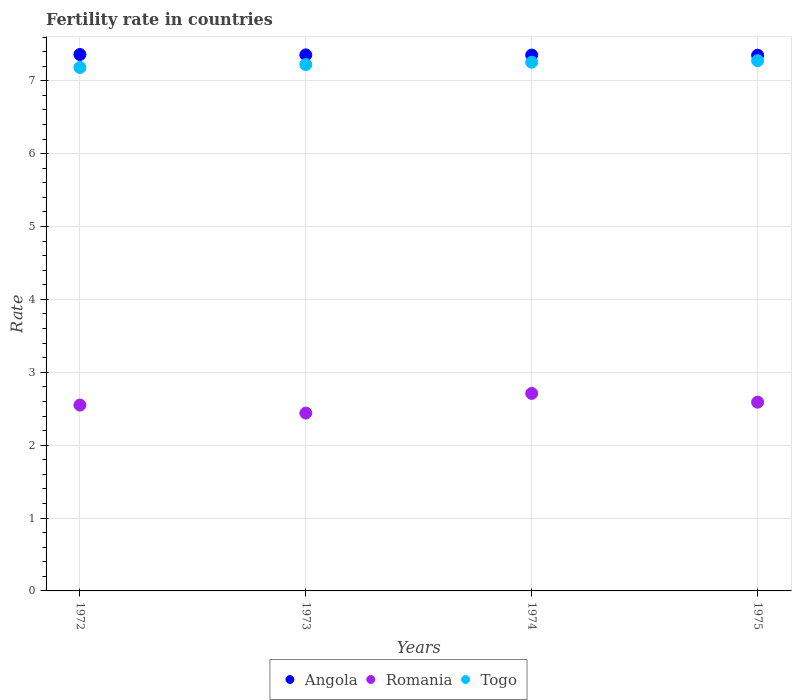How many different coloured dotlines are there?
Ensure brevity in your answer.  3. Is the number of dotlines equal to the number of legend labels?
Provide a short and direct response. Yes. What is the fertility rate in Angola in 1974?
Provide a succinct answer. 7.35. Across all years, what is the maximum fertility rate in Romania?
Ensure brevity in your answer.  2.71. Across all years, what is the minimum fertility rate in Togo?
Your response must be concise. 7.18. In which year was the fertility rate in Angola maximum?
Your answer should be compact. 1972. In which year was the fertility rate in Romania minimum?
Give a very brief answer. 1973. What is the total fertility rate in Togo in the graph?
Give a very brief answer. 28.93. What is the difference between the fertility rate in Angola in 1972 and that in 1975?
Keep it short and to the point. 0.01. What is the difference between the fertility rate in Romania in 1975 and the fertility rate in Togo in 1972?
Provide a short and direct response. -4.59. What is the average fertility rate in Romania per year?
Your answer should be very brief. 2.57. In the year 1975, what is the difference between the fertility rate in Angola and fertility rate in Romania?
Make the answer very short. 4.76. In how many years, is the fertility rate in Angola greater than 2?
Give a very brief answer. 4. What is the ratio of the fertility rate in Angola in 1973 to that in 1974?
Offer a terse response. 1. What is the difference between the highest and the second highest fertility rate in Togo?
Give a very brief answer. 0.02. What is the difference between the highest and the lowest fertility rate in Togo?
Offer a very short reply. 0.09. In how many years, is the fertility rate in Togo greater than the average fertility rate in Togo taken over all years?
Give a very brief answer. 2. Is it the case that in every year, the sum of the fertility rate in Angola and fertility rate in Romania  is greater than the fertility rate in Togo?
Give a very brief answer. Yes. How many years are there in the graph?
Your answer should be very brief. 4. Does the graph contain any zero values?
Provide a succinct answer. No. What is the title of the graph?
Offer a terse response. Fertility rate in countries. Does "Moldova" appear as one of the legend labels in the graph?
Provide a succinct answer. No. What is the label or title of the Y-axis?
Keep it short and to the point. Rate. What is the Rate of Angola in 1972?
Your answer should be compact. 7.36. What is the Rate of Romania in 1972?
Provide a succinct answer. 2.55. What is the Rate in Togo in 1972?
Keep it short and to the point. 7.18. What is the Rate in Angola in 1973?
Offer a terse response. 7.36. What is the Rate in Romania in 1973?
Make the answer very short. 2.44. What is the Rate in Togo in 1973?
Keep it short and to the point. 7.22. What is the Rate in Angola in 1974?
Provide a succinct answer. 7.35. What is the Rate in Romania in 1974?
Give a very brief answer. 2.71. What is the Rate in Togo in 1974?
Ensure brevity in your answer.  7.25. What is the Rate in Angola in 1975?
Provide a succinct answer. 7.35. What is the Rate in Romania in 1975?
Your answer should be very brief. 2.59. What is the Rate of Togo in 1975?
Give a very brief answer. 7.28. Across all years, what is the maximum Rate of Angola?
Your response must be concise. 7.36. Across all years, what is the maximum Rate of Romania?
Keep it short and to the point. 2.71. Across all years, what is the maximum Rate of Togo?
Offer a terse response. 7.28. Across all years, what is the minimum Rate of Angola?
Ensure brevity in your answer.  7.35. Across all years, what is the minimum Rate in Romania?
Your response must be concise. 2.44. Across all years, what is the minimum Rate in Togo?
Your answer should be very brief. 7.18. What is the total Rate in Angola in the graph?
Provide a succinct answer. 29.42. What is the total Rate in Romania in the graph?
Give a very brief answer. 10.29. What is the total Rate in Togo in the graph?
Your answer should be compact. 28.93. What is the difference between the Rate of Angola in 1972 and that in 1973?
Give a very brief answer. 0.01. What is the difference between the Rate in Romania in 1972 and that in 1973?
Ensure brevity in your answer.  0.11. What is the difference between the Rate of Togo in 1972 and that in 1973?
Give a very brief answer. -0.04. What is the difference between the Rate in Angola in 1972 and that in 1974?
Ensure brevity in your answer.  0.01. What is the difference between the Rate of Romania in 1972 and that in 1974?
Offer a very short reply. -0.16. What is the difference between the Rate of Togo in 1972 and that in 1974?
Offer a very short reply. -0.07. What is the difference between the Rate of Romania in 1972 and that in 1975?
Provide a short and direct response. -0.04. What is the difference between the Rate of Togo in 1972 and that in 1975?
Provide a succinct answer. -0.09. What is the difference between the Rate in Angola in 1973 and that in 1974?
Offer a very short reply. 0. What is the difference between the Rate in Romania in 1973 and that in 1974?
Provide a succinct answer. -0.27. What is the difference between the Rate in Togo in 1973 and that in 1974?
Your response must be concise. -0.03. What is the difference between the Rate in Angola in 1973 and that in 1975?
Provide a short and direct response. 0.01. What is the difference between the Rate in Romania in 1973 and that in 1975?
Provide a short and direct response. -0.15. What is the difference between the Rate of Togo in 1973 and that in 1975?
Offer a very short reply. -0.05. What is the difference between the Rate in Angola in 1974 and that in 1975?
Keep it short and to the point. 0. What is the difference between the Rate in Romania in 1974 and that in 1975?
Your answer should be compact. 0.12. What is the difference between the Rate of Togo in 1974 and that in 1975?
Your answer should be compact. -0.02. What is the difference between the Rate in Angola in 1972 and the Rate in Romania in 1973?
Your answer should be compact. 4.92. What is the difference between the Rate of Angola in 1972 and the Rate of Togo in 1973?
Give a very brief answer. 0.14. What is the difference between the Rate in Romania in 1972 and the Rate in Togo in 1973?
Give a very brief answer. -4.67. What is the difference between the Rate in Angola in 1972 and the Rate in Romania in 1974?
Your answer should be very brief. 4.65. What is the difference between the Rate of Angola in 1972 and the Rate of Togo in 1974?
Provide a short and direct response. 0.11. What is the difference between the Rate of Romania in 1972 and the Rate of Togo in 1974?
Offer a very short reply. -4.7. What is the difference between the Rate of Angola in 1972 and the Rate of Romania in 1975?
Provide a short and direct response. 4.77. What is the difference between the Rate in Angola in 1972 and the Rate in Togo in 1975?
Offer a terse response. 0.09. What is the difference between the Rate of Romania in 1972 and the Rate of Togo in 1975?
Your response must be concise. -4.72. What is the difference between the Rate of Angola in 1973 and the Rate of Romania in 1974?
Offer a terse response. 4.64. What is the difference between the Rate of Angola in 1973 and the Rate of Togo in 1974?
Your answer should be very brief. 0.1. What is the difference between the Rate in Romania in 1973 and the Rate in Togo in 1974?
Make the answer very short. -4.81. What is the difference between the Rate in Angola in 1973 and the Rate in Romania in 1975?
Your answer should be very brief. 4.76. What is the difference between the Rate in Romania in 1973 and the Rate in Togo in 1975?
Make the answer very short. -4.83. What is the difference between the Rate of Angola in 1974 and the Rate of Romania in 1975?
Offer a terse response. 4.76. What is the difference between the Rate of Angola in 1974 and the Rate of Togo in 1975?
Keep it short and to the point. 0.08. What is the difference between the Rate in Romania in 1974 and the Rate in Togo in 1975?
Offer a terse response. -4.57. What is the average Rate of Angola per year?
Provide a short and direct response. 7.35. What is the average Rate of Romania per year?
Provide a succinct answer. 2.57. What is the average Rate of Togo per year?
Make the answer very short. 7.23. In the year 1972, what is the difference between the Rate of Angola and Rate of Romania?
Offer a terse response. 4.81. In the year 1972, what is the difference between the Rate in Angola and Rate in Togo?
Provide a short and direct response. 0.18. In the year 1972, what is the difference between the Rate of Romania and Rate of Togo?
Ensure brevity in your answer.  -4.63. In the year 1973, what is the difference between the Rate of Angola and Rate of Romania?
Your answer should be compact. 4.92. In the year 1973, what is the difference between the Rate of Angola and Rate of Togo?
Your answer should be very brief. 0.13. In the year 1973, what is the difference between the Rate of Romania and Rate of Togo?
Give a very brief answer. -4.78. In the year 1974, what is the difference between the Rate in Angola and Rate in Romania?
Provide a short and direct response. 4.64. In the year 1974, what is the difference between the Rate of Angola and Rate of Togo?
Provide a succinct answer. 0.1. In the year 1974, what is the difference between the Rate in Romania and Rate in Togo?
Your response must be concise. -4.54. In the year 1975, what is the difference between the Rate in Angola and Rate in Romania?
Offer a terse response. 4.76. In the year 1975, what is the difference between the Rate in Angola and Rate in Togo?
Your answer should be very brief. 0.07. In the year 1975, what is the difference between the Rate of Romania and Rate of Togo?
Keep it short and to the point. -4.68. What is the ratio of the Rate of Romania in 1972 to that in 1973?
Offer a very short reply. 1.05. What is the ratio of the Rate of Romania in 1972 to that in 1974?
Your response must be concise. 0.94. What is the ratio of the Rate of Angola in 1972 to that in 1975?
Give a very brief answer. 1. What is the ratio of the Rate of Romania in 1972 to that in 1975?
Ensure brevity in your answer.  0.98. What is the ratio of the Rate in Togo in 1972 to that in 1975?
Make the answer very short. 0.99. What is the ratio of the Rate in Romania in 1973 to that in 1974?
Provide a short and direct response. 0.9. What is the ratio of the Rate in Togo in 1973 to that in 1974?
Make the answer very short. 1. What is the ratio of the Rate of Angola in 1973 to that in 1975?
Make the answer very short. 1. What is the ratio of the Rate of Romania in 1973 to that in 1975?
Provide a short and direct response. 0.94. What is the ratio of the Rate of Togo in 1973 to that in 1975?
Offer a very short reply. 0.99. What is the ratio of the Rate of Romania in 1974 to that in 1975?
Give a very brief answer. 1.05. What is the ratio of the Rate in Togo in 1974 to that in 1975?
Provide a short and direct response. 1. What is the difference between the highest and the second highest Rate of Angola?
Provide a short and direct response. 0.01. What is the difference between the highest and the second highest Rate of Romania?
Provide a short and direct response. 0.12. What is the difference between the highest and the second highest Rate in Togo?
Ensure brevity in your answer.  0.02. What is the difference between the highest and the lowest Rate in Romania?
Ensure brevity in your answer.  0.27. What is the difference between the highest and the lowest Rate in Togo?
Keep it short and to the point. 0.09. 